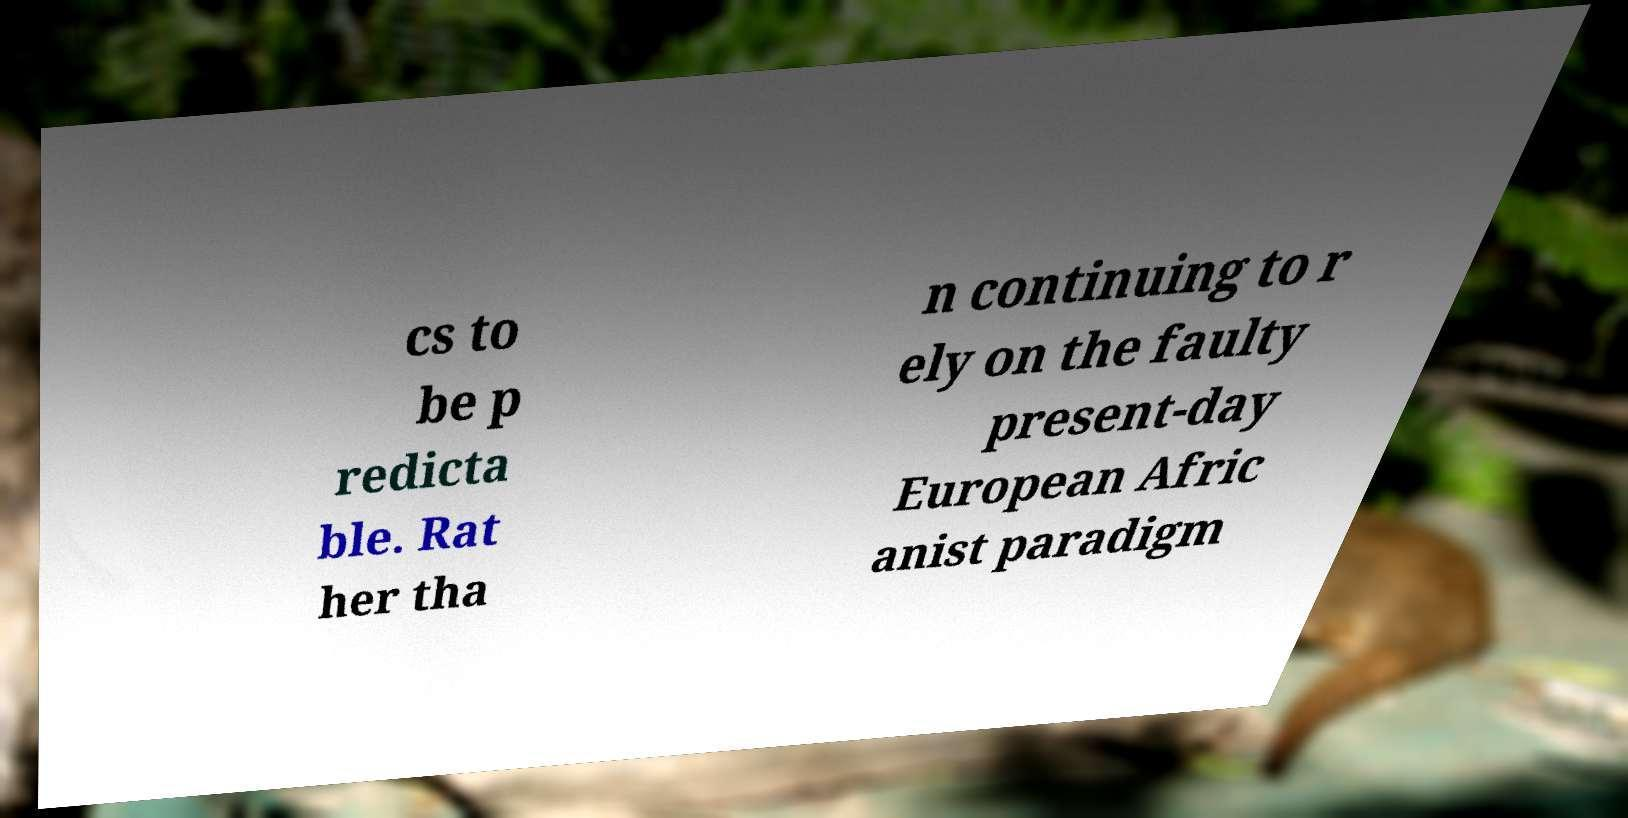Could you assist in decoding the text presented in this image and type it out clearly? cs to be p redicta ble. Rat her tha n continuing to r ely on the faulty present-day European Afric anist paradigm 